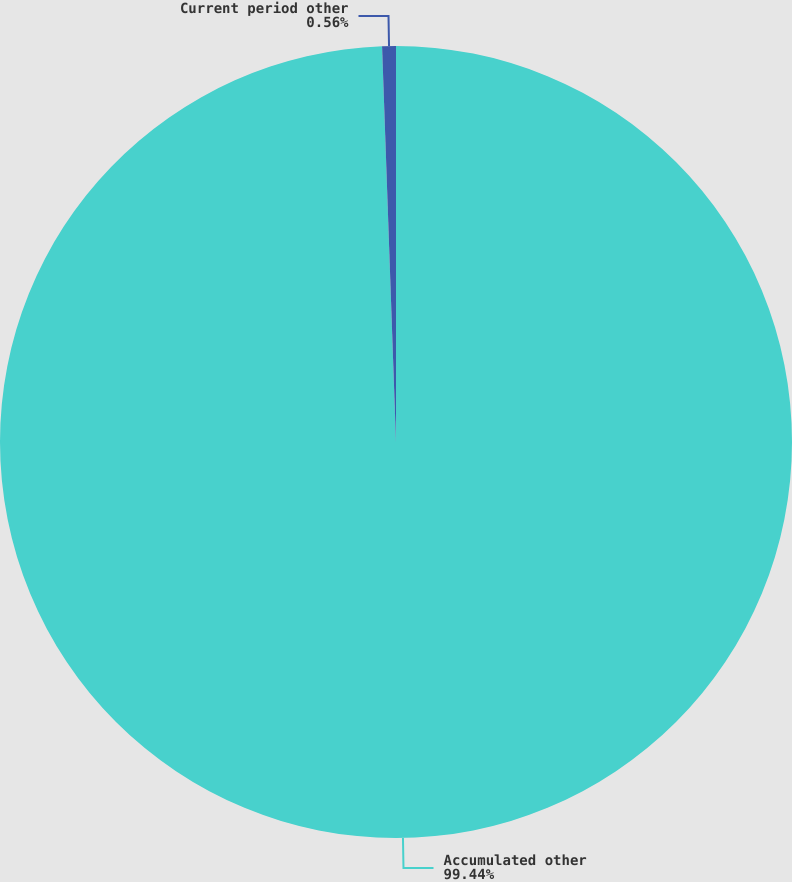Convert chart. <chart><loc_0><loc_0><loc_500><loc_500><pie_chart><fcel>Accumulated other<fcel>Current period other<nl><fcel>99.44%<fcel>0.56%<nl></chart> 